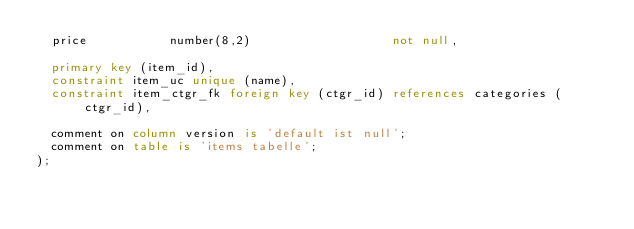<code> <loc_0><loc_0><loc_500><loc_500><_SQL_>  price           number(8,2)                   not null,

  primary key (item_id),
  constraint item_uc unique (name),
  constraint item_ctgr_fk foreign key (ctgr_id) references categories (ctgr_id),

  comment on column version is 'default ist null';
  comment on table is 'items tabelle';  
);

</code> 